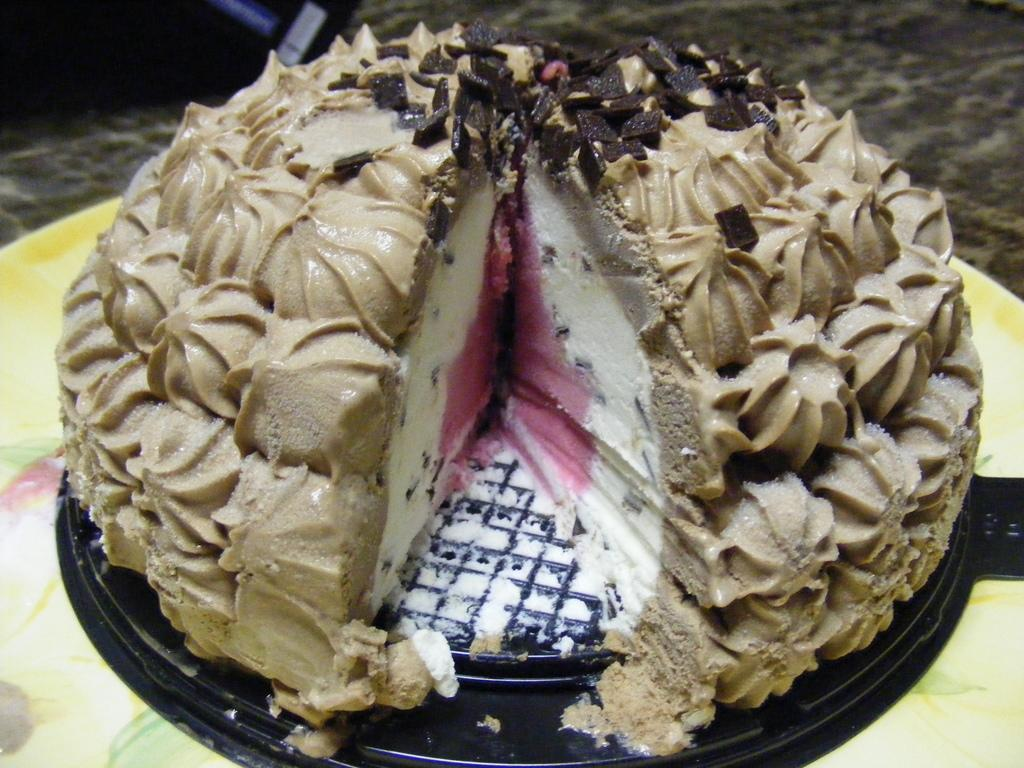What is the main subject in the center of the image? There is a cake in the center of the image. Where is the cake located? The cake is on a table. What type of straw is used to decorate the cake in the image? There is no straw present on the cake in the image. What appliance is used to bake the cake in the image? The image does not show the process of baking the cake or any appliances used in the process. 